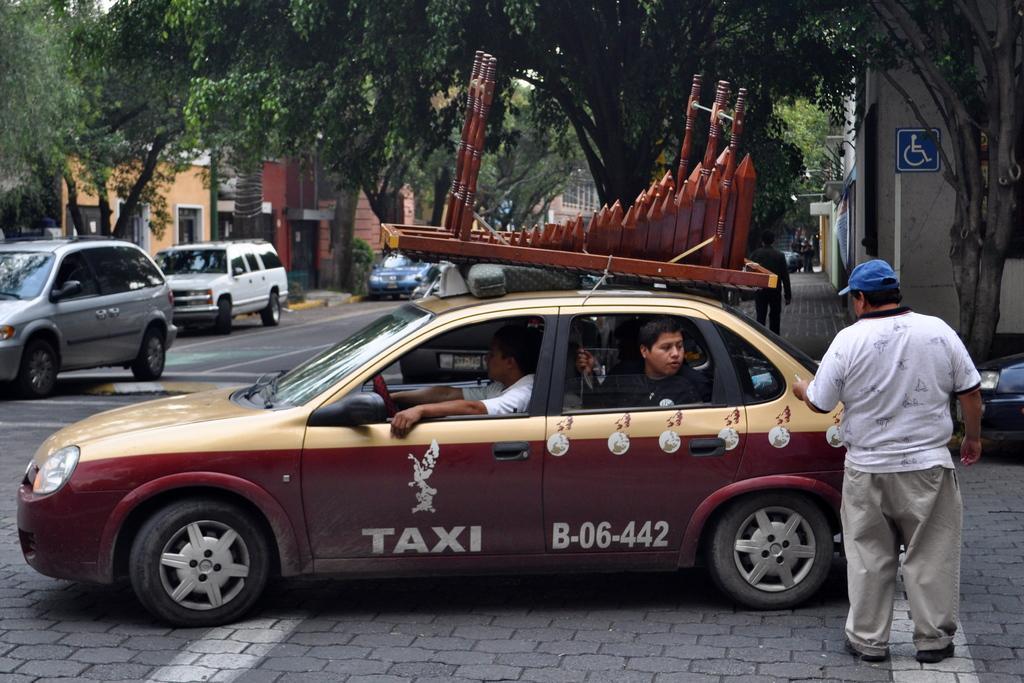Could you give a brief overview of what you see in this image? An outdoor picture. This vehicle is highlighted in this picture. These are trees. A vehicles on road. These are buildings. The man in white t-shirt is standing and wore cap. This is a sign board. Persons are sitting inside this vehicle. 